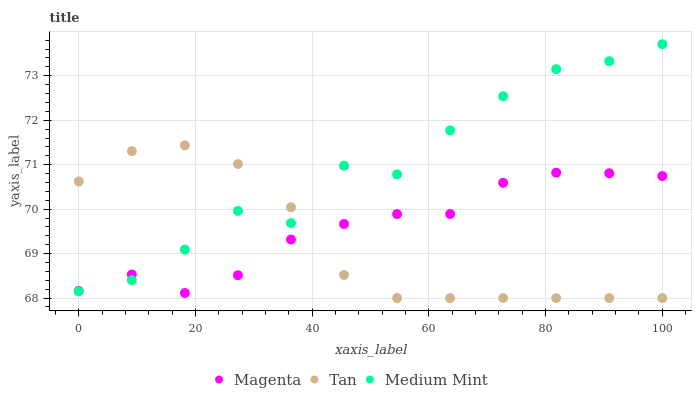Does Tan have the minimum area under the curve?
Answer yes or no. Yes. Does Medium Mint have the maximum area under the curve?
Answer yes or no. Yes. Does Magenta have the minimum area under the curve?
Answer yes or no. No. Does Magenta have the maximum area under the curve?
Answer yes or no. No. Is Tan the smoothest?
Answer yes or no. Yes. Is Medium Mint the roughest?
Answer yes or no. Yes. Is Magenta the smoothest?
Answer yes or no. No. Is Magenta the roughest?
Answer yes or no. No. Does Tan have the lowest value?
Answer yes or no. Yes. Does Magenta have the lowest value?
Answer yes or no. No. Does Medium Mint have the highest value?
Answer yes or no. Yes. Does Tan have the highest value?
Answer yes or no. No. Does Tan intersect Medium Mint?
Answer yes or no. Yes. Is Tan less than Medium Mint?
Answer yes or no. No. Is Tan greater than Medium Mint?
Answer yes or no. No. 